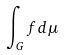Convert formula to latex. <formula><loc_0><loc_0><loc_500><loc_500>\int _ { G } f d \mu</formula> 